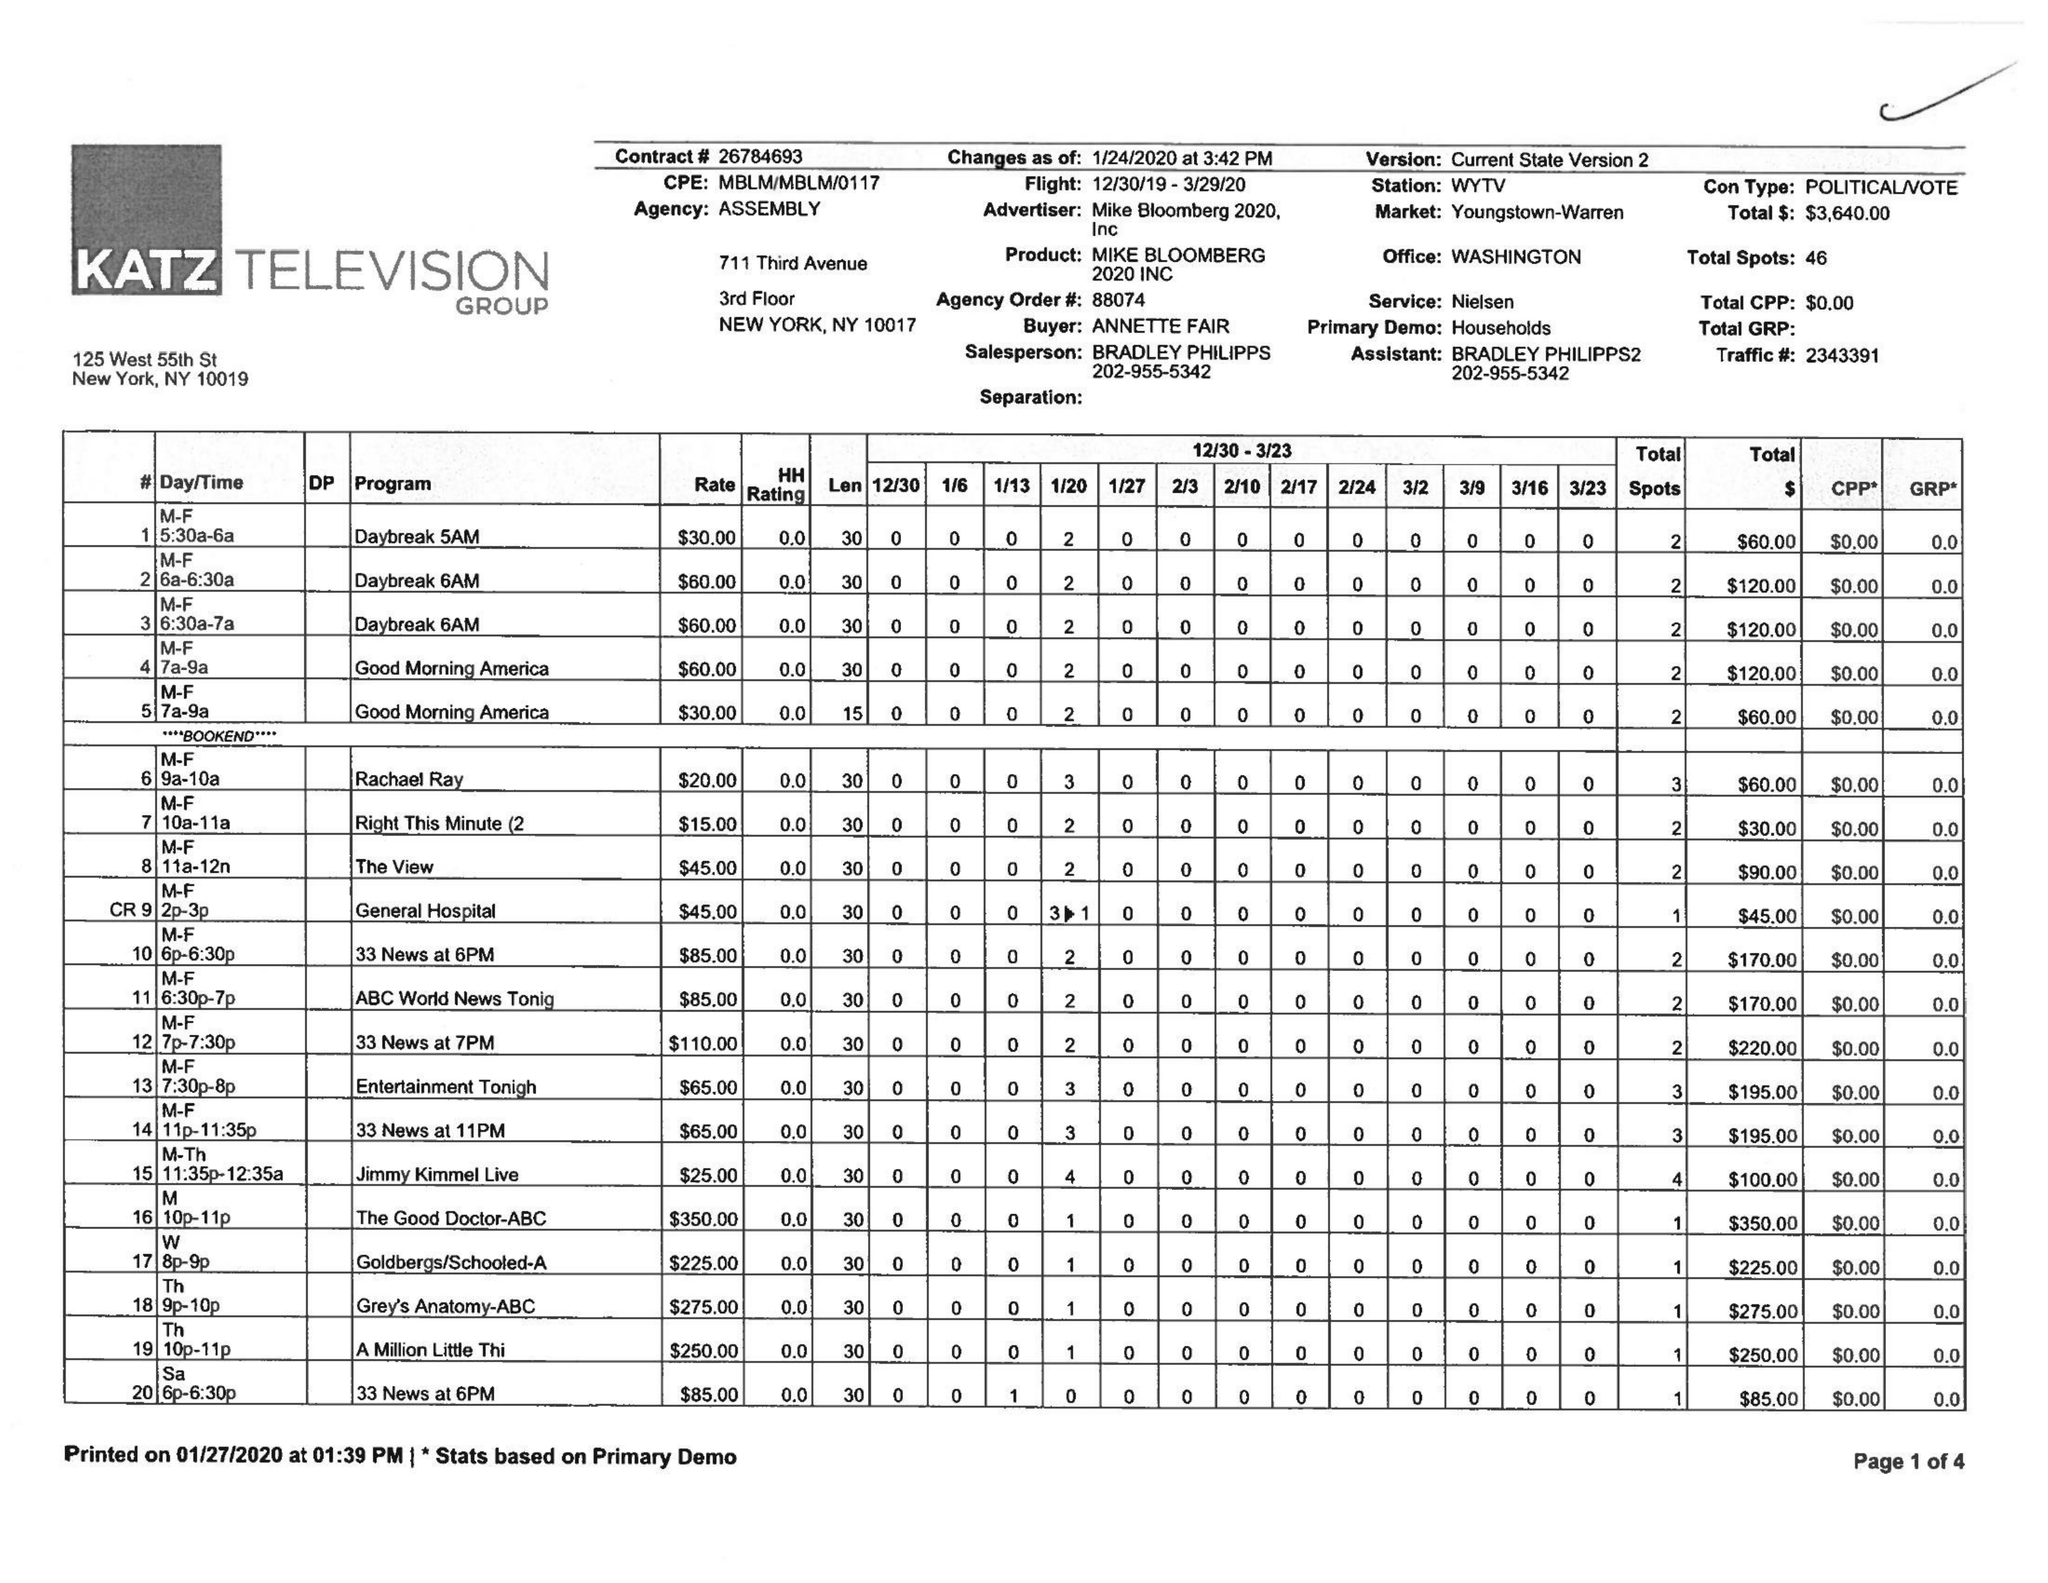What is the value for the advertiser?
Answer the question using a single word or phrase. MIKE BLOOMBERG 2020, INC 